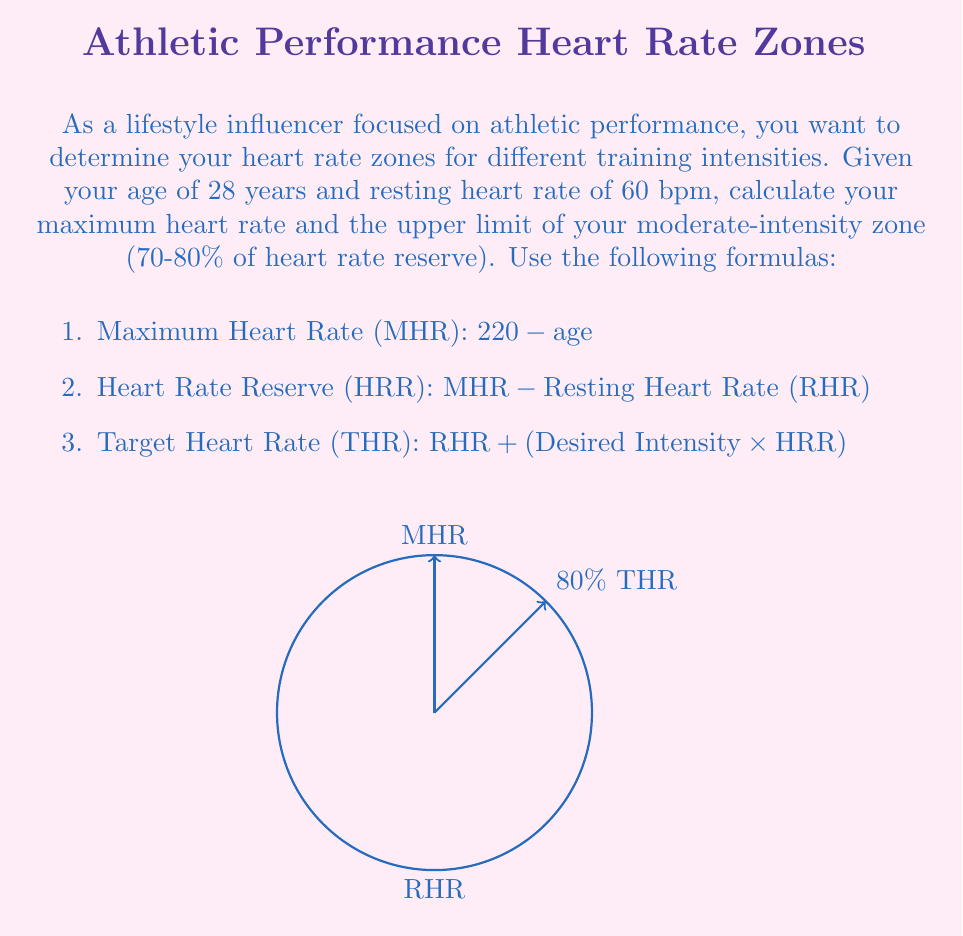Solve this math problem. Let's solve this problem step by step:

1. Calculate Maximum Heart Rate (MHR):
   $$\text{MHR} = 220 - \text{age} = 220 - 28 = 192 \text{ bpm}$$

2. Calculate Heart Rate Reserve (HRR):
   $$\text{HRR} = \text{MHR} - \text{RHR} = 192 - 60 = 132 \text{ bpm}$$

3. Calculate the upper limit of the moderate-intensity zone (80% of HRR):
   $$\text{THR} = \text{RHR} + (0.80 \times \text{HRR})$$
   $$\text{THR} = 60 + (0.80 \times 132)$$
   $$\text{THR} = 60 + 105.6$$
   $$\text{THR} = 165.6 \text{ bpm}$$

Therefore, the upper limit of your moderate-intensity zone is approximately 166 bpm (rounded to the nearest whole number).
Answer: 166 bpm 